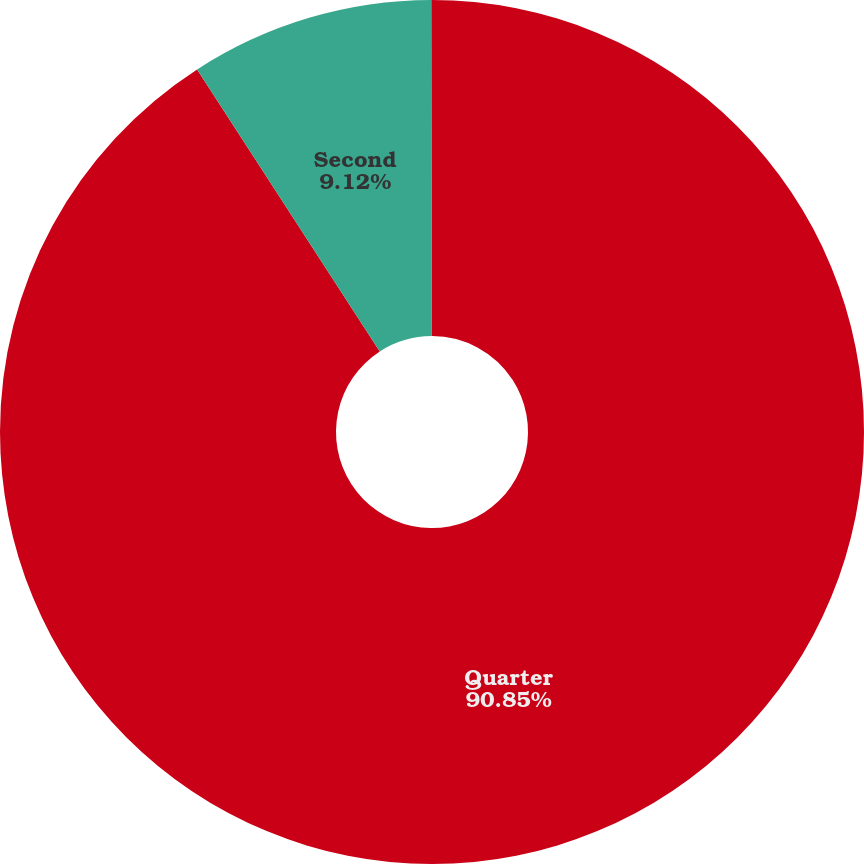Convert chart to OTSL. <chart><loc_0><loc_0><loc_500><loc_500><pie_chart><fcel>Quarter<fcel>Second<fcel>Third<nl><fcel>90.85%<fcel>9.12%<fcel>0.03%<nl></chart> 